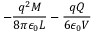Convert formula to latex. <formula><loc_0><loc_0><loc_500><loc_500>- \frac { q ^ { 2 } M } { 8 \pi \epsilon _ { 0 } L } - \frac { q Q } { 6 \epsilon _ { 0 } V }</formula> 